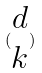Convert formula to latex. <formula><loc_0><loc_0><loc_500><loc_500>( \begin{matrix} d \\ k \end{matrix} )</formula> 